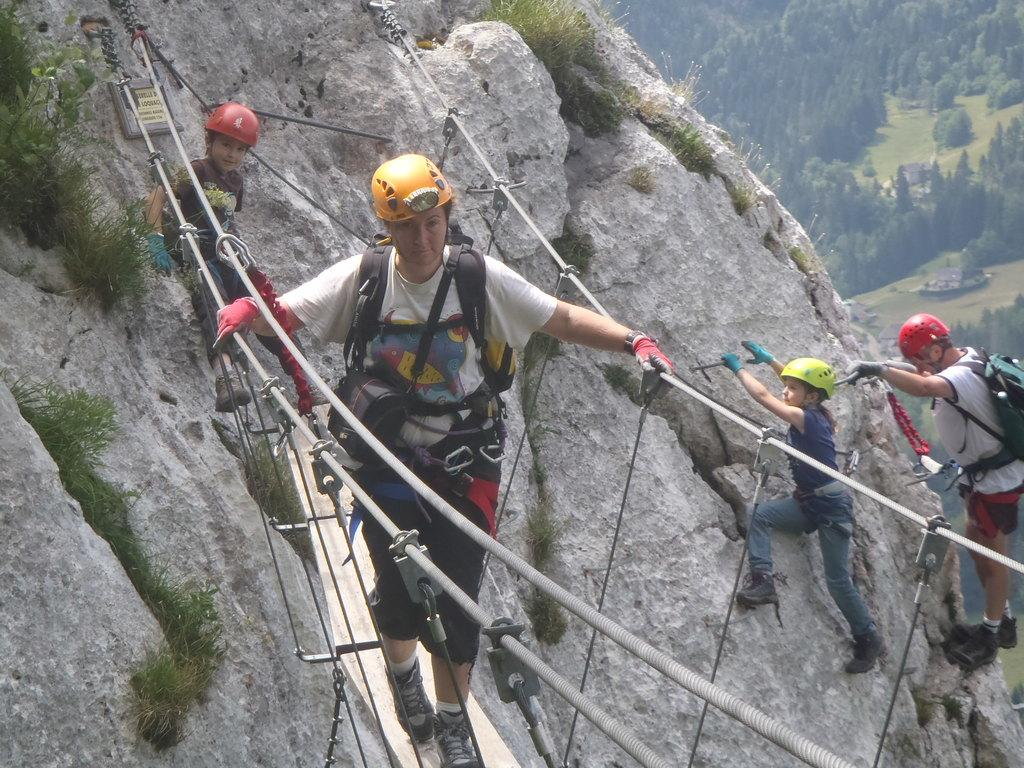What is the main subject of the picture? There is a person walking in the middle of the picture. Are there any other people in the image? Yes, there are two members on the right side of the picture. What can be seen in the background of the picture? There are trees in the background of the picture. Where is the throne located in the image? There is no throne present in the image. What type of fire can be seen in the image? There is no fire present in the image. 